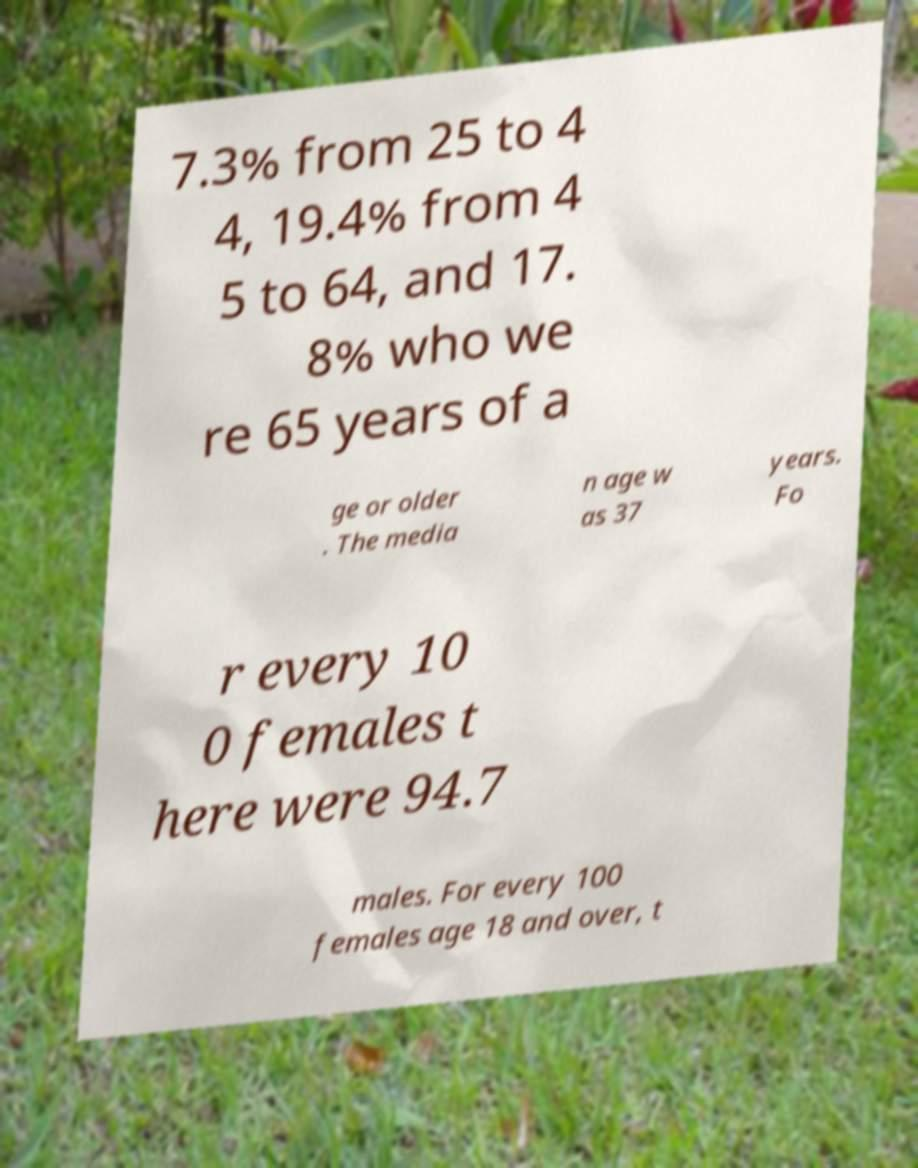Can you accurately transcribe the text from the provided image for me? 7.3% from 25 to 4 4, 19.4% from 4 5 to 64, and 17. 8% who we re 65 years of a ge or older . The media n age w as 37 years. Fo r every 10 0 females t here were 94.7 males. For every 100 females age 18 and over, t 